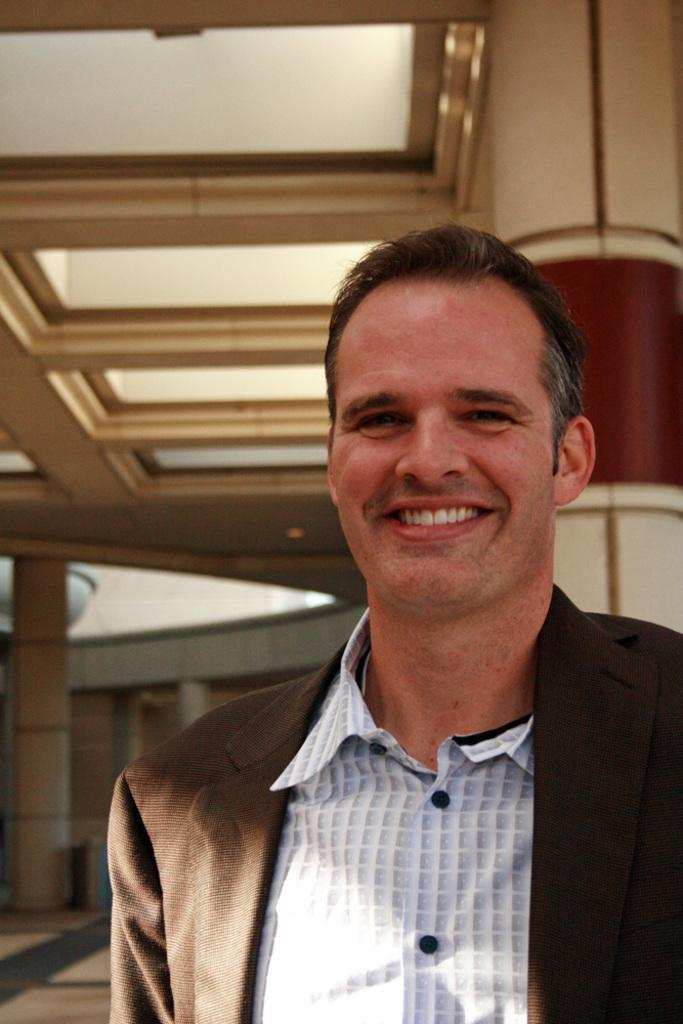What is the main subject in the foreground of the image? There is a person on the floor in the foreground of the image. What can be seen in the background of the image? There is a wall, doors, and a pillar in the image. What architectural feature is visible in the image? There is a rooftop in the image. What type of location might the image depict? The image may have been taken in a hall. What type of drink is being served on the furniture in the image? There is no drink or furniture present in the image. 